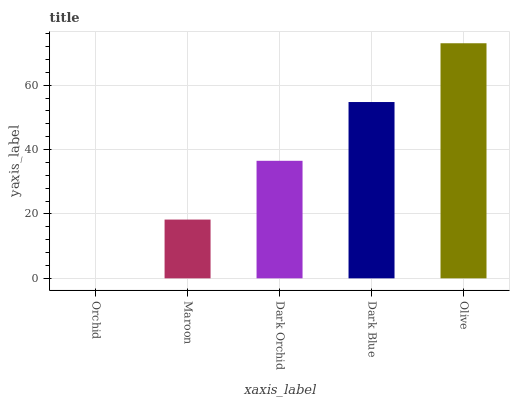Is Orchid the minimum?
Answer yes or no. Yes. Is Olive the maximum?
Answer yes or no. Yes. Is Maroon the minimum?
Answer yes or no. No. Is Maroon the maximum?
Answer yes or no. No. Is Maroon greater than Orchid?
Answer yes or no. Yes. Is Orchid less than Maroon?
Answer yes or no. Yes. Is Orchid greater than Maroon?
Answer yes or no. No. Is Maroon less than Orchid?
Answer yes or no. No. Is Dark Orchid the high median?
Answer yes or no. Yes. Is Dark Orchid the low median?
Answer yes or no. Yes. Is Olive the high median?
Answer yes or no. No. Is Dark Blue the low median?
Answer yes or no. No. 